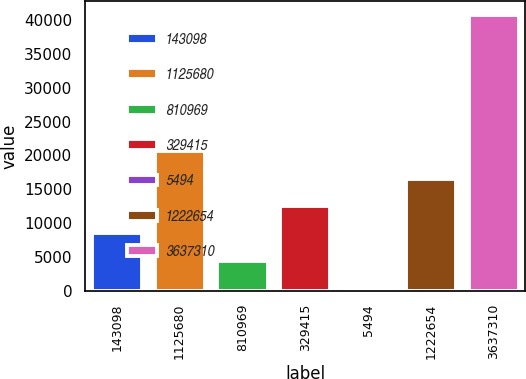Convert chart to OTSL. <chart><loc_0><loc_0><loc_500><loc_500><bar_chart><fcel>143098<fcel>1125680<fcel>810969<fcel>329415<fcel>5494<fcel>1222654<fcel>3637310<nl><fcel>8485.2<fcel>20589<fcel>4450.6<fcel>12519.8<fcel>416<fcel>16554.4<fcel>40762<nl></chart> 